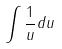Convert formula to latex. <formula><loc_0><loc_0><loc_500><loc_500>\int \frac { 1 } { u } d u</formula> 